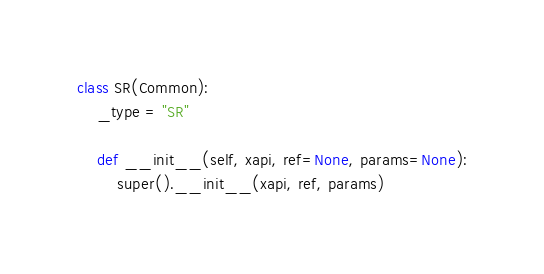Convert code to text. <code><loc_0><loc_0><loc_500><loc_500><_Python_>
class SR(Common):
    _type = "SR"

    def __init__(self, xapi, ref=None, params=None):
        super().__init__(xapi, ref, params)
</code> 